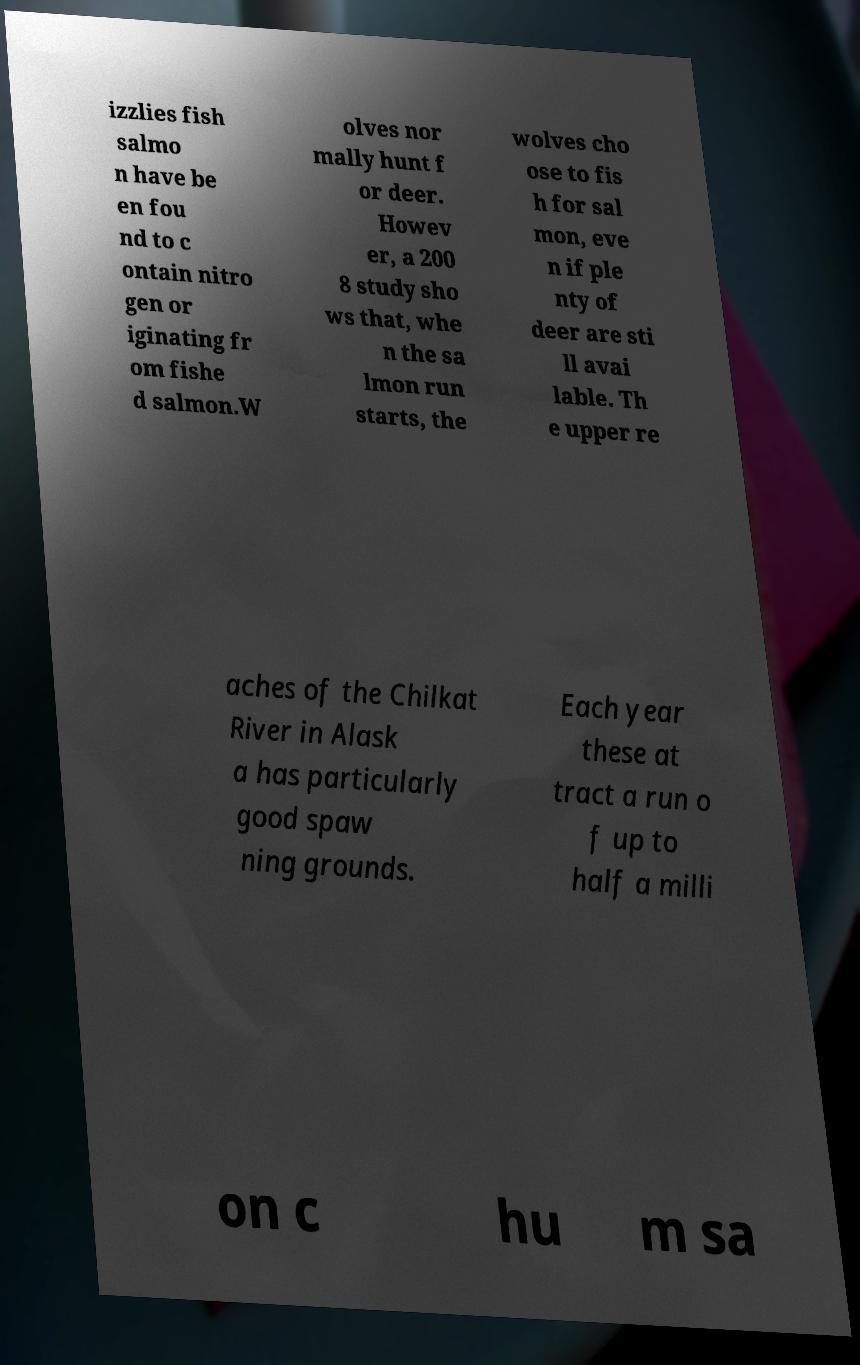For documentation purposes, I need the text within this image transcribed. Could you provide that? izzlies fish salmo n have be en fou nd to c ontain nitro gen or iginating fr om fishe d salmon.W olves nor mally hunt f or deer. Howev er, a 200 8 study sho ws that, whe n the sa lmon run starts, the wolves cho ose to fis h for sal mon, eve n if ple nty of deer are sti ll avai lable. Th e upper re aches of the Chilkat River in Alask a has particularly good spaw ning grounds. Each year these at tract a run o f up to half a milli on c hu m sa 